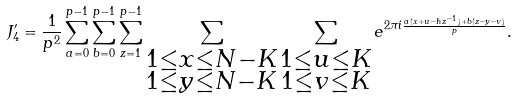Convert formula to latex. <formula><loc_0><loc_0><loc_500><loc_500>J _ { 4 } ^ { \prime } = \frac { 1 } { p ^ { 2 } } \sum _ { a = 0 } ^ { p - 1 } \sum _ { b = 0 } ^ { p - 1 } \sum _ { z = 1 } ^ { p - 1 } \sum _ { \substack { 1 \leq x \leq N - K \\ 1 \leq y \leq N - K } } \sum _ { \substack { 1 \leq u \leq K \\ 1 \leq v \leq K } } e ^ { 2 \pi i \frac { a ( x + u - h z ^ { - 1 } ) + b ( z - y - v ) } { p } } .</formula> 